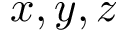<formula> <loc_0><loc_0><loc_500><loc_500>x , y , z</formula> 